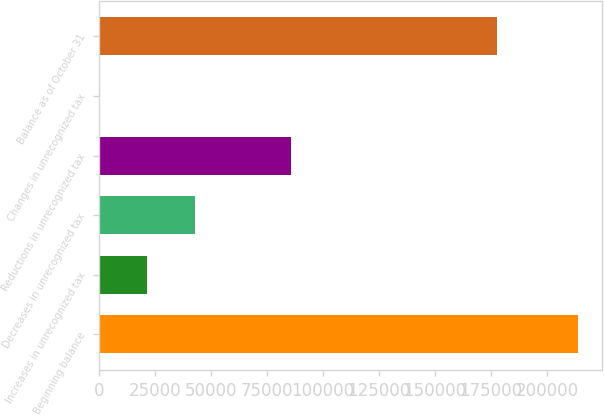Convert chart. <chart><loc_0><loc_0><loc_500><loc_500><bar_chart><fcel>Beginning balance<fcel>Increases in unrecognized tax<fcel>Decreases in unrecognized tax<fcel>Reductions in unrecognized tax<fcel>Changes in unrecognized tax<fcel>Balance as of October 31<nl><fcel>213923<fcel>21418.4<fcel>42807.8<fcel>85586.6<fcel>29<fcel>177893<nl></chart> 